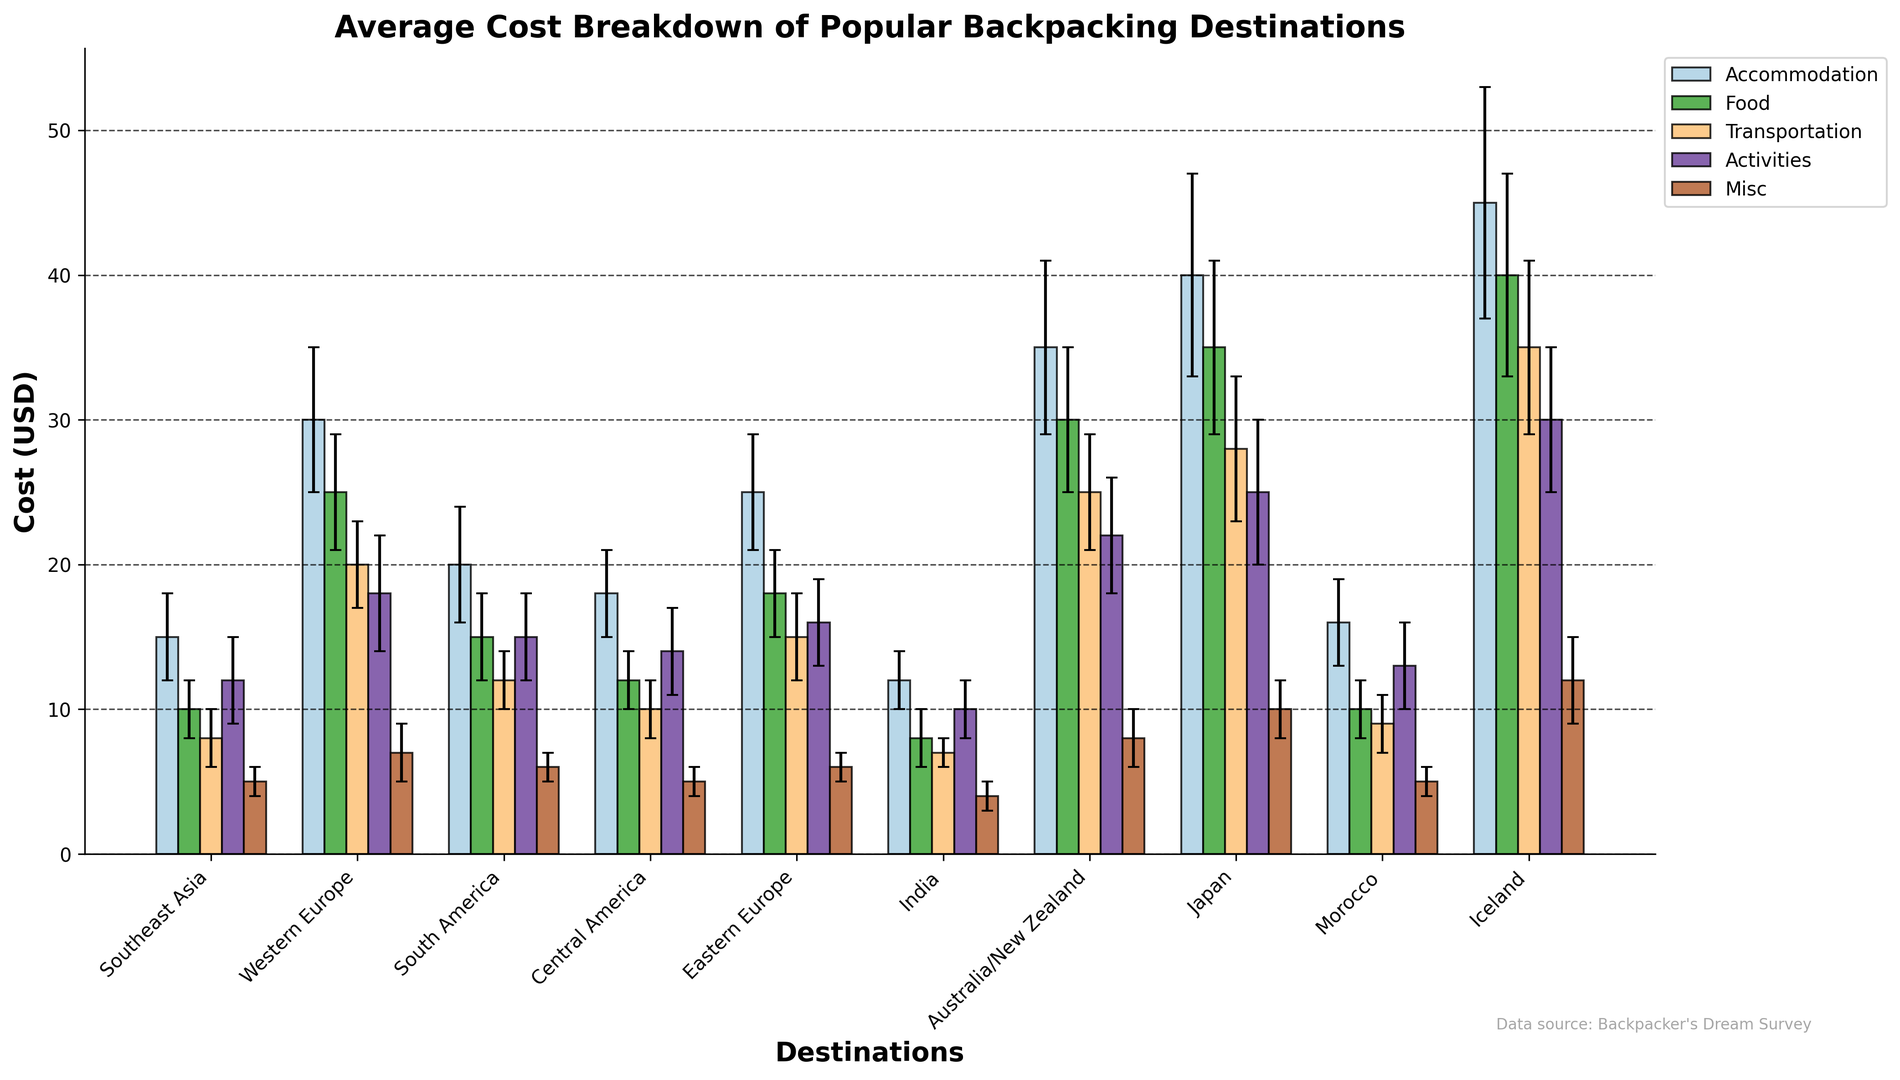Which destination has the highest overall cost? To answer this, look for the bar corresponding to the 'Total' value, which represents the sum of all expense categories, and find the one with the greatest height.
Answer: Iceland Which two destinations have the most similar costs for food? Compare the heights of the 'Food' bars for each destination, focusing on their height and their error bars. The destinations with the closest values are Japan and Iceland.
Answer: Japan and Iceland What is the approximate average transportation cost across all destinations? Extract the values of the 'Transportation' expenses, add them up, and then divide by the number of destinations. (8 + 20 + 12 + 10 + 15 + 7 + 25 + 28 + 9 + 35) / 10 = 16.9
Answer: 16.9 Which expense category has the largest variation in costs across different destinations? Look for the category with the largest range in bar heights across destinations, including their error bars. The 'Accommodation' category shows the most variation from 12±2 in India to 45±8 in Iceland.
Answer: Accommodation How does the cost of activities in Southeast Asia compare to those in Japan? Observe the heights of the 'Activities' bars for Southeast Asia and Japan, noting that Southeast Asia is lower.
Answer: Lower Between Australia/New Zealand and Central America, which destination has a higher food cost, and by how much? Compare the height of the 'Food' bars for Australia/New Zealand (30) and Central America (12) and calculate the difference. 30 - 12 = 18
Answer: Australia/New Zealand, by 18 What is the combined cost of accommodation and transportation in South America? Add the heights of 'Accommodation' and 'Transportation' bars for South America. 20 + 12 = 32
Answer: 32 Which destination has the lowest cost for accommodation? Find the shortest 'Accommodation' bar. The lowest cost for accommodation is in India.
Answer: India Excluding the error bars, which category has the least contribution to the overall cost in Western Europe? Compare the heights of the bars within Western Europe. The 'Misc' bar is the shortest at 7.
Answer: Misc Compare the transportation costs between Eastern Europe and Morocco. Which is cheaper and by how much? Look at the heights of the 'Transportation' bars for Eastern Europe and Morocco, noting that 15 (Eastern Europe) - 9 (Morocco) = 6
Answer: Morocco, by 6 